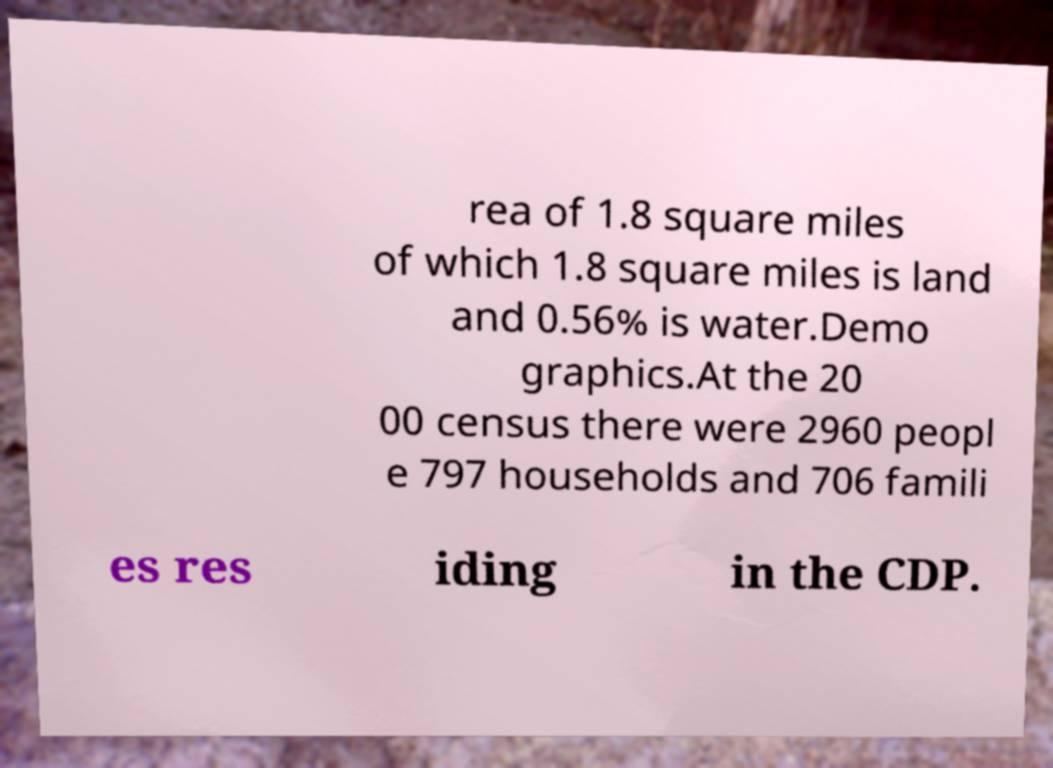Please identify and transcribe the text found in this image. rea of 1.8 square miles of which 1.8 square miles is land and 0.56% is water.Demo graphics.At the 20 00 census there were 2960 peopl e 797 households and 706 famili es res iding in the CDP. 